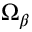<formula> <loc_0><loc_0><loc_500><loc_500>\Omega _ { \beta }</formula> 